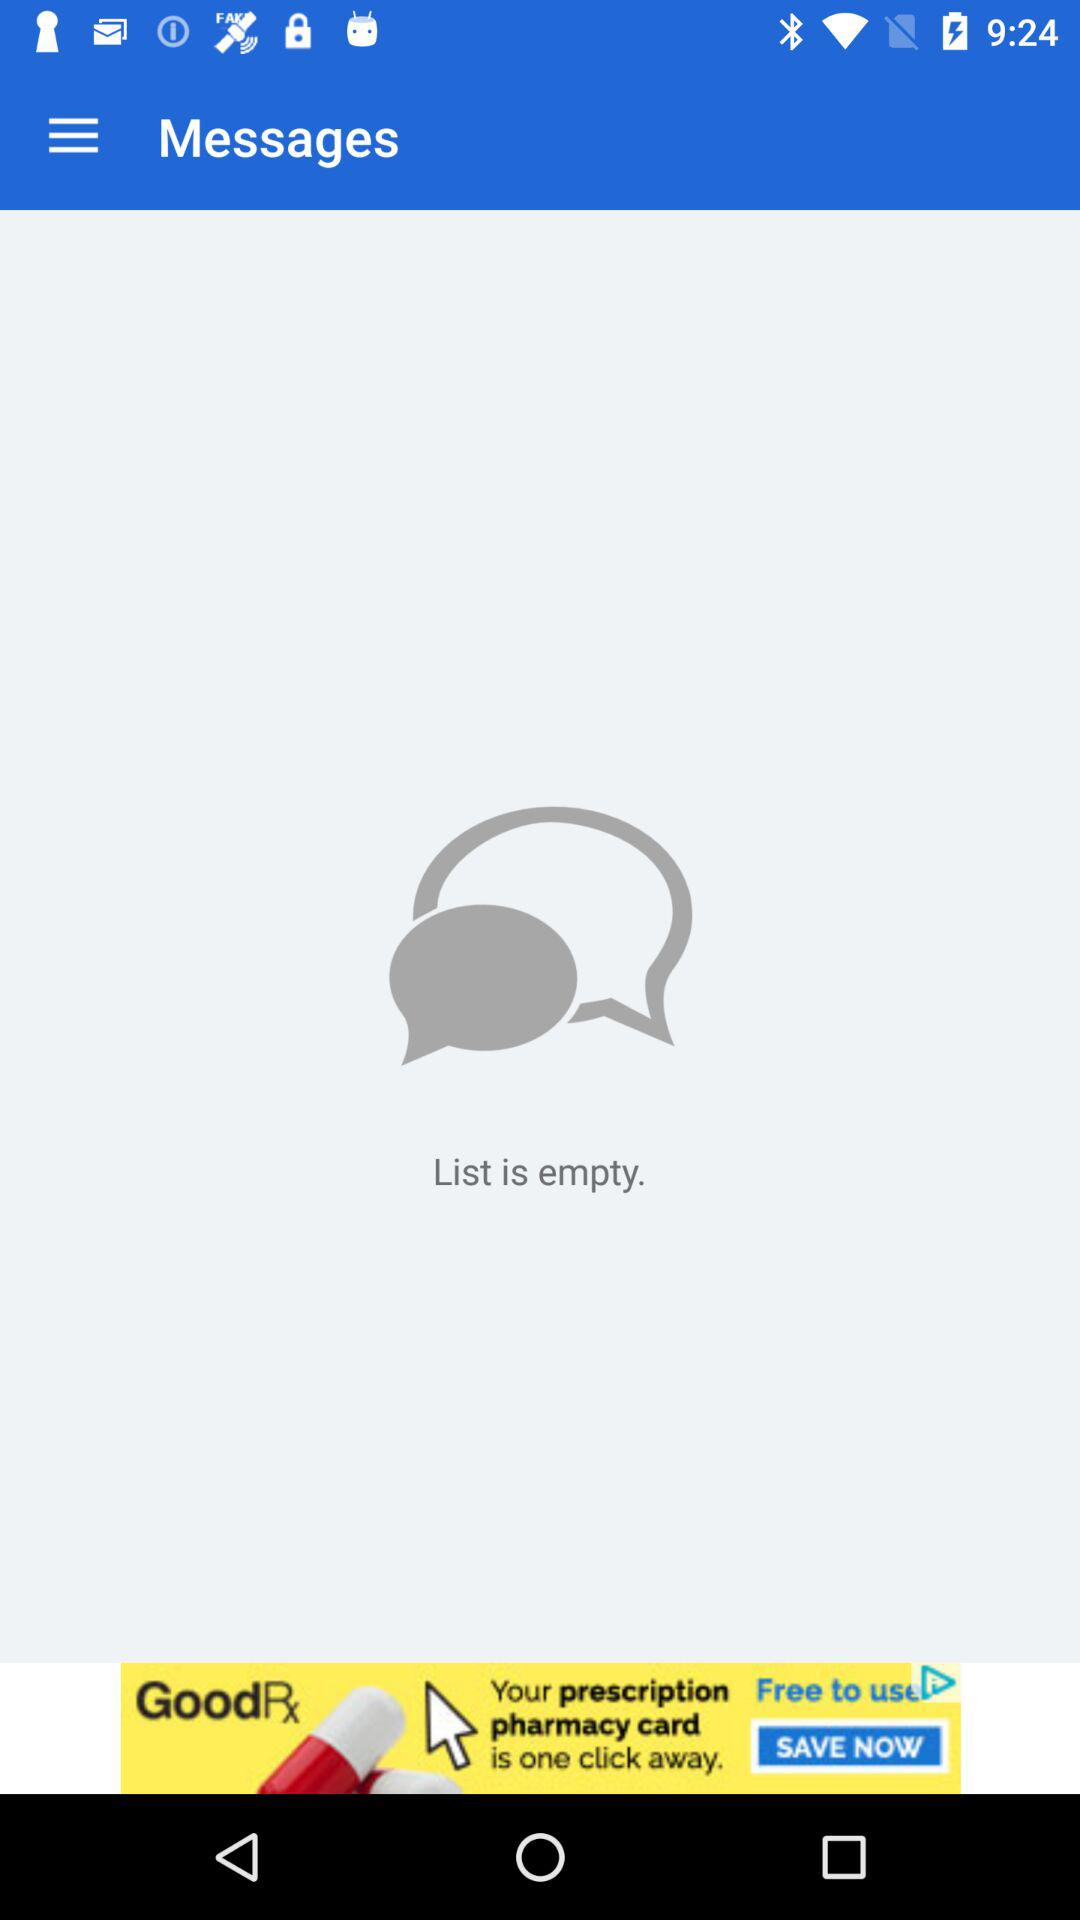How many items are in the list? The list is empty. 